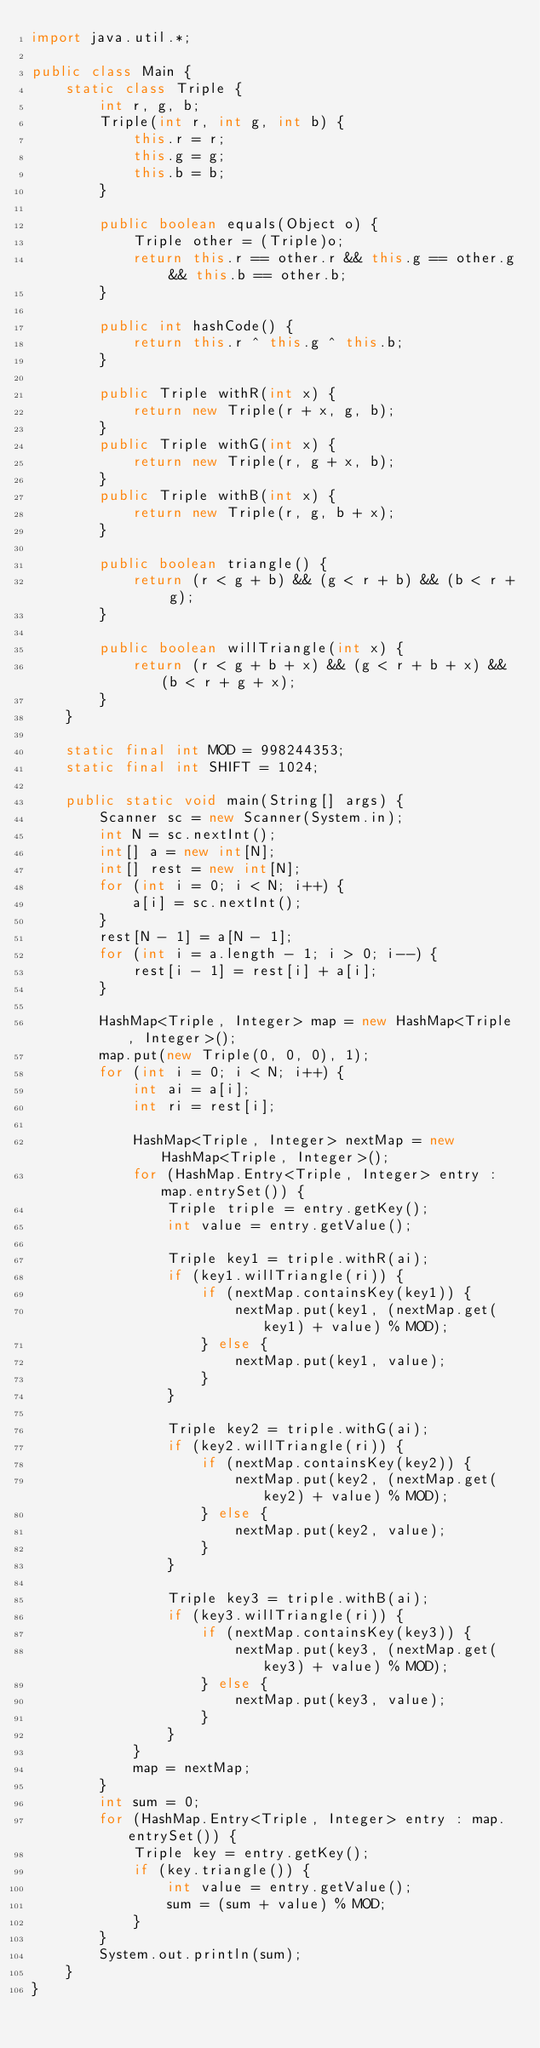Convert code to text. <code><loc_0><loc_0><loc_500><loc_500><_Java_>import java.util.*;

public class Main {
    static class Triple {
        int r, g, b;
        Triple(int r, int g, int b) {
            this.r = r;
            this.g = g;
            this.b = b;
        }

        public boolean equals(Object o) {
            Triple other = (Triple)o;
            return this.r == other.r && this.g == other.g && this.b == other.b;
        }

        public int hashCode() {
            return this.r ^ this.g ^ this.b;
        }

        public Triple withR(int x) {
            return new Triple(r + x, g, b);
        }
        public Triple withG(int x) {
            return new Triple(r, g + x, b);
        }
        public Triple withB(int x) {
            return new Triple(r, g, b + x);
        }

        public boolean triangle() {
            return (r < g + b) && (g < r + b) && (b < r + g);
        }

        public boolean willTriangle(int x) {
            return (r < g + b + x) && (g < r + b + x) && (b < r + g + x);
        }
    }

    static final int MOD = 998244353;
    static final int SHIFT = 1024;

    public static void main(String[] args) {
        Scanner sc = new Scanner(System.in);
        int N = sc.nextInt();
        int[] a = new int[N];
        int[] rest = new int[N];
        for (int i = 0; i < N; i++) {
            a[i] = sc.nextInt();
        }
        rest[N - 1] = a[N - 1];
        for (int i = a.length - 1; i > 0; i--) {
            rest[i - 1] = rest[i] + a[i];
        }

        HashMap<Triple, Integer> map = new HashMap<Triple, Integer>();
        map.put(new Triple(0, 0, 0), 1);
        for (int i = 0; i < N; i++) {
            int ai = a[i];
            int ri = rest[i];

            HashMap<Triple, Integer> nextMap = new HashMap<Triple, Integer>();
            for (HashMap.Entry<Triple, Integer> entry : map.entrySet()) {
                Triple triple = entry.getKey();
                int value = entry.getValue();

                Triple key1 = triple.withR(ai);
                if (key1.willTriangle(ri)) {
                    if (nextMap.containsKey(key1)) {
                        nextMap.put(key1, (nextMap.get(key1) + value) % MOD);
                    } else {
                        nextMap.put(key1, value);
                    }
                }

                Triple key2 = triple.withG(ai);
                if (key2.willTriangle(ri)) {
                    if (nextMap.containsKey(key2)) {
                        nextMap.put(key2, (nextMap.get(key2) + value) % MOD);
                    } else {
                        nextMap.put(key2, value);
                    }
                }

                Triple key3 = triple.withB(ai);
                if (key3.willTriangle(ri)) {
                    if (nextMap.containsKey(key3)) {
                        nextMap.put(key3, (nextMap.get(key3) + value) % MOD);
                    } else {
                        nextMap.put(key3, value);
                    }
                }
            }
            map = nextMap;
        }
        int sum = 0;
        for (HashMap.Entry<Triple, Integer> entry : map.entrySet()) {
            Triple key = entry.getKey();
            if (key.triangle()) {
                int value = entry.getValue();
                sum = (sum + value) % MOD;
            }
        }
        System.out.println(sum);
    }
}</code> 